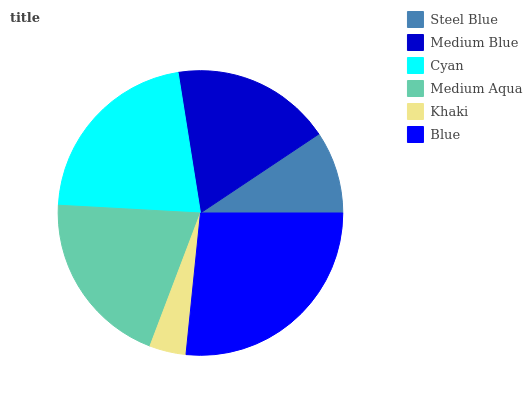Is Khaki the minimum?
Answer yes or no. Yes. Is Blue the maximum?
Answer yes or no. Yes. Is Medium Blue the minimum?
Answer yes or no. No. Is Medium Blue the maximum?
Answer yes or no. No. Is Medium Blue greater than Steel Blue?
Answer yes or no. Yes. Is Steel Blue less than Medium Blue?
Answer yes or no. Yes. Is Steel Blue greater than Medium Blue?
Answer yes or no. No. Is Medium Blue less than Steel Blue?
Answer yes or no. No. Is Medium Aqua the high median?
Answer yes or no. Yes. Is Medium Blue the low median?
Answer yes or no. Yes. Is Medium Blue the high median?
Answer yes or no. No. Is Steel Blue the low median?
Answer yes or no. No. 